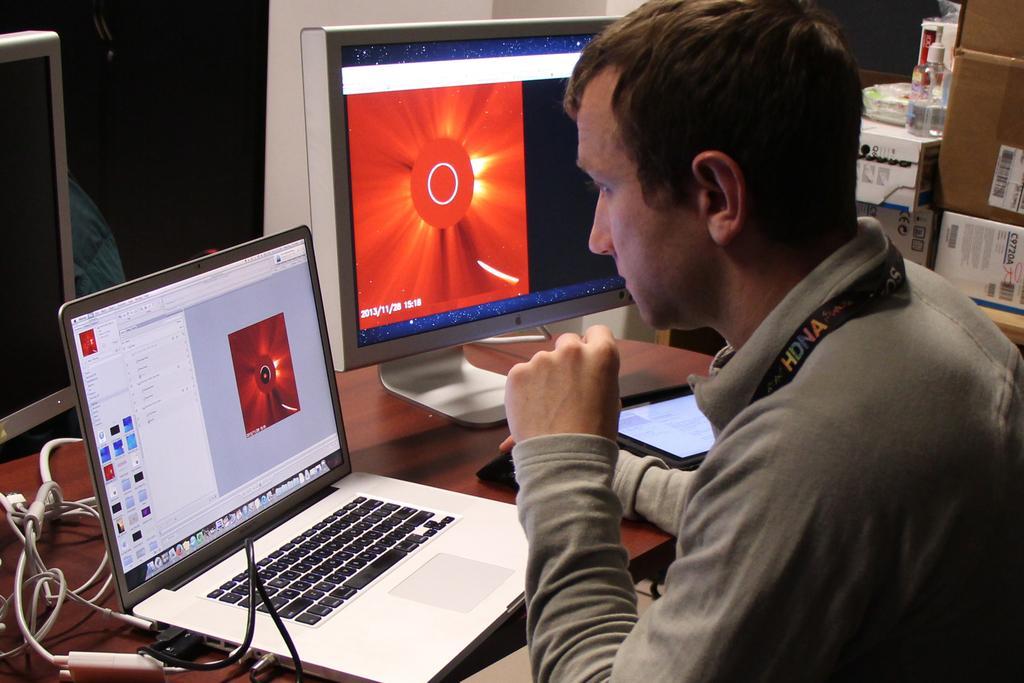Can you describe this image briefly? In this image there is a person sitting in front of the table. On the table there are two monitors, cables, laptop, mouse and iPad and there are other objects placed beside the person. 